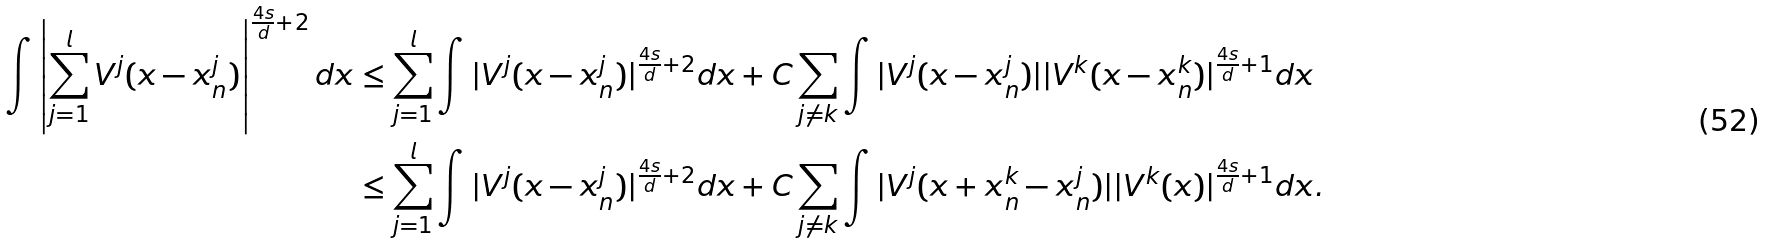<formula> <loc_0><loc_0><loc_500><loc_500>\int \left | \sum _ { j = 1 } ^ { l } V ^ { j } ( x - x ^ { j } _ { n } ) \right | ^ { \frac { 4 s } { d } + 2 } d x & \leq \sum _ { j = 1 } ^ { l } \int | V ^ { j } ( x - x ^ { j } _ { n } ) | ^ { \frac { 4 s } { d } + 2 } d x + C \sum _ { j \ne k } \int | V ^ { j } ( x - x ^ { j } _ { n } ) | | V ^ { k } ( x - x ^ { k } _ { n } ) | ^ { \frac { 4 s } { d } + 1 } d x \\ & \leq \sum _ { j = 1 } ^ { l } \int | V ^ { j } ( x - x ^ { j } _ { n } ) | ^ { \frac { 4 s } { d } + 2 } d x + C \sum _ { j \ne k } \int | V ^ { j } ( x + x ^ { k } _ { n } - x ^ { j } _ { n } ) | | V ^ { k } ( x ) | ^ { \frac { 4 s } { d } + 1 } d x .</formula> 